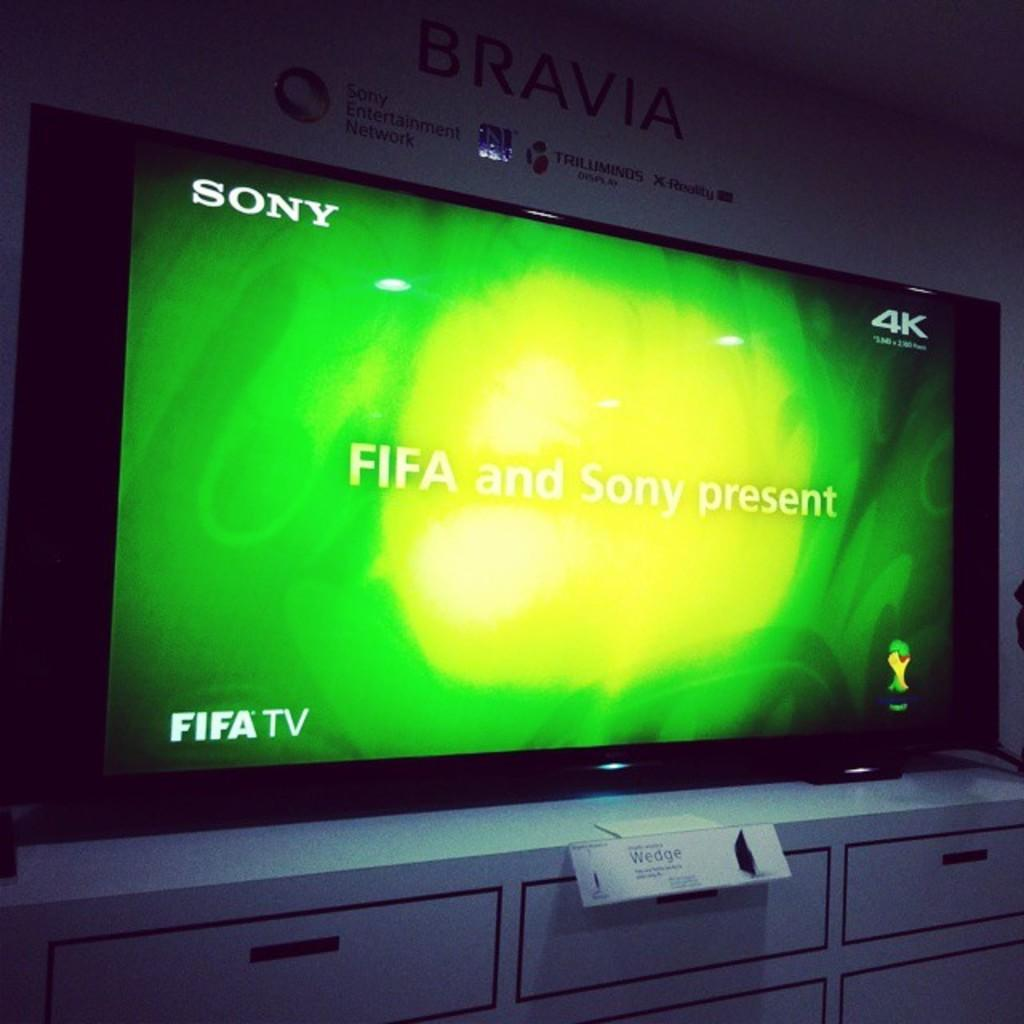<image>
Provide a brief description of the given image. A Fifa TV displayed on a wall the maker is Sony and the screen shows FIFA and SONY present. 